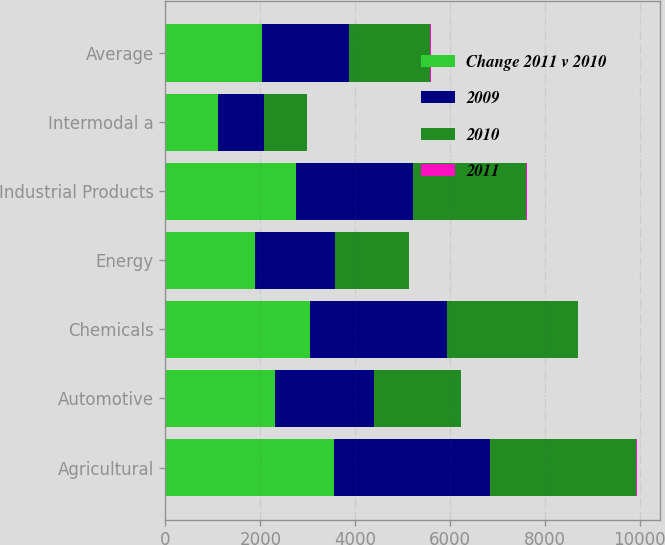Convert chart. <chart><loc_0><loc_0><loc_500><loc_500><stacked_bar_chart><ecel><fcel>Agricultural<fcel>Automotive<fcel>Chemicals<fcel>Energy<fcel>Industrial Products<fcel>Intermodal a<fcel>Average<nl><fcel>Change 2011 v 2010<fcel>3561<fcel>2311<fcel>3055<fcel>1888<fcel>2762<fcel>1109<fcel>2040<nl><fcel>2009<fcel>3286<fcel>2082<fcel>2874<fcel>1697<fcel>2461<fcel>974<fcel>1823<nl><fcel>2010<fcel>3080<fcel>1838<fcel>2761<fcel>1543<fcel>2388<fcel>896<fcel>1718<nl><fcel>2011<fcel>8<fcel>11<fcel>6<fcel>11<fcel>12<fcel>14<fcel>12<nl></chart> 